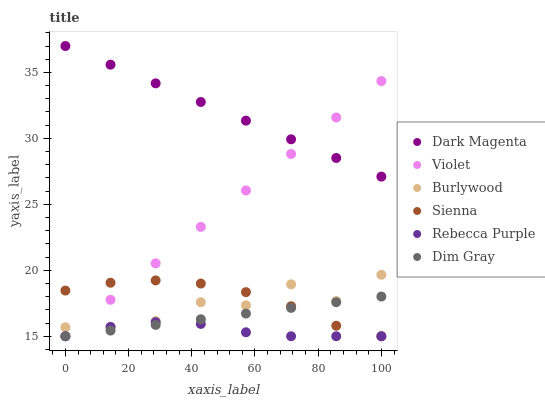Does Rebecca Purple have the minimum area under the curve?
Answer yes or no. Yes. Does Dark Magenta have the maximum area under the curve?
Answer yes or no. Yes. Does Burlywood have the minimum area under the curve?
Answer yes or no. No. Does Burlywood have the maximum area under the curve?
Answer yes or no. No. Is Dim Gray the smoothest?
Answer yes or no. Yes. Is Burlywood the roughest?
Answer yes or no. Yes. Is Dark Magenta the smoothest?
Answer yes or no. No. Is Dark Magenta the roughest?
Answer yes or no. No. Does Dim Gray have the lowest value?
Answer yes or no. Yes. Does Burlywood have the lowest value?
Answer yes or no. No. Does Dark Magenta have the highest value?
Answer yes or no. Yes. Does Burlywood have the highest value?
Answer yes or no. No. Is Dim Gray less than Burlywood?
Answer yes or no. Yes. Is Dark Magenta greater than Rebecca Purple?
Answer yes or no. Yes. Does Dark Magenta intersect Violet?
Answer yes or no. Yes. Is Dark Magenta less than Violet?
Answer yes or no. No. Is Dark Magenta greater than Violet?
Answer yes or no. No. Does Dim Gray intersect Burlywood?
Answer yes or no. No. 